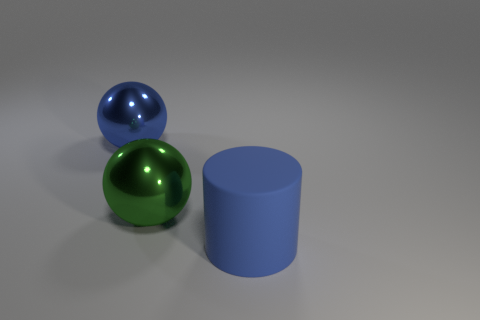Add 3 big balls. How many objects exist? 6 Subtract all balls. How many objects are left? 1 Add 3 large spheres. How many large spheres are left? 5 Add 3 big blue things. How many big blue things exist? 5 Subtract 0 purple spheres. How many objects are left? 3 Subtract all large blue matte cylinders. Subtract all blue rubber cylinders. How many objects are left? 1 